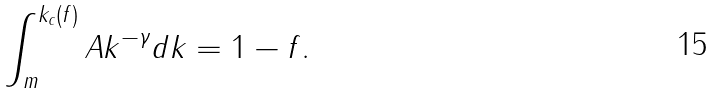Convert formula to latex. <formula><loc_0><loc_0><loc_500><loc_500>\int ^ { k _ { c } ( f ) } _ { m } A k ^ { - \gamma } d k = 1 - f .</formula> 